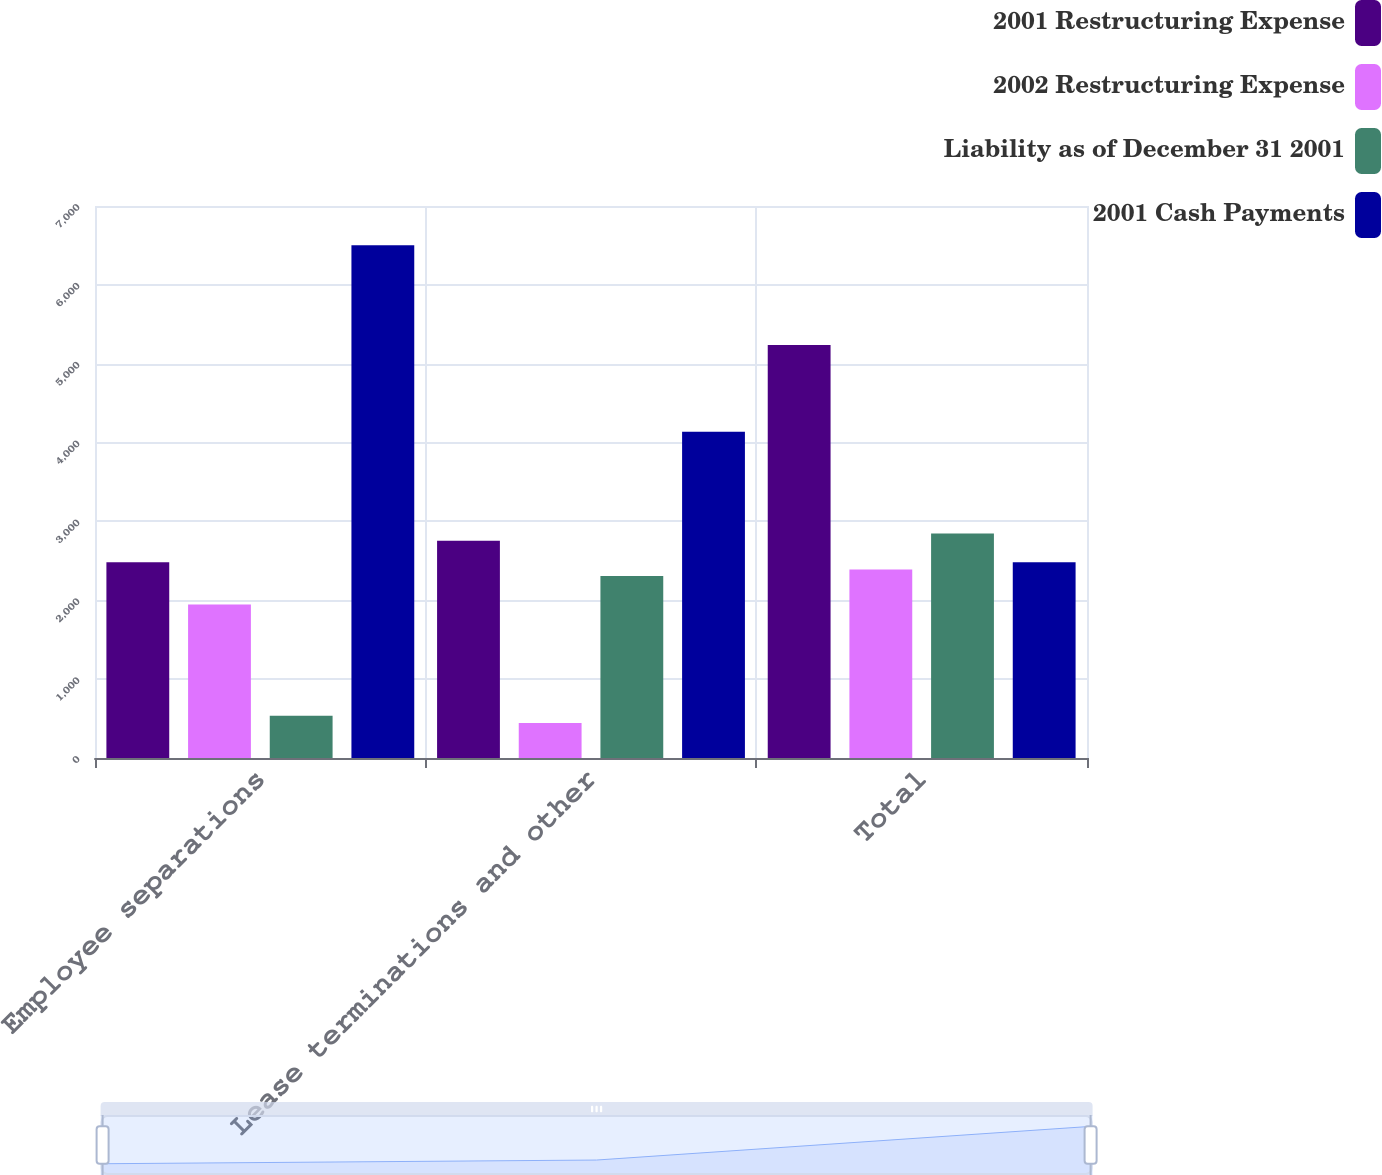Convert chart. <chart><loc_0><loc_0><loc_500><loc_500><stacked_bar_chart><ecel><fcel>Employee separations<fcel>Lease terminations and other<fcel>Total<nl><fcel>2001 Restructuring Expense<fcel>2482<fcel>2754<fcel>5236<nl><fcel>2002 Restructuring Expense<fcel>1945<fcel>445<fcel>2390<nl><fcel>Liability as of December 31 2001<fcel>537<fcel>2309<fcel>2846<nl><fcel>2001 Cash Payments<fcel>6501<fcel>4137<fcel>2482<nl></chart> 